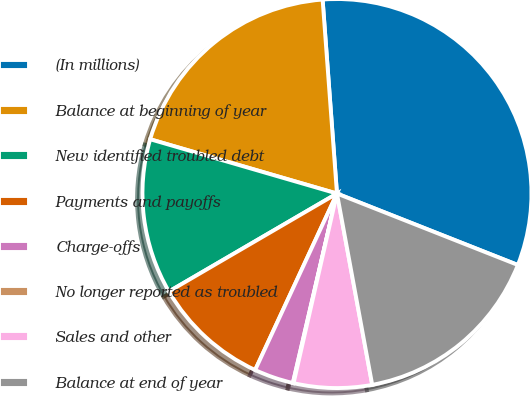Convert chart to OTSL. <chart><loc_0><loc_0><loc_500><loc_500><pie_chart><fcel>(In millions)<fcel>Balance at beginning of year<fcel>New identified troubled debt<fcel>Payments and payoffs<fcel>Charge-offs<fcel>No longer reported as troubled<fcel>Sales and other<fcel>Balance at end of year<nl><fcel>32.16%<fcel>19.32%<fcel>12.9%<fcel>9.69%<fcel>3.27%<fcel>0.06%<fcel>6.48%<fcel>16.11%<nl></chart> 